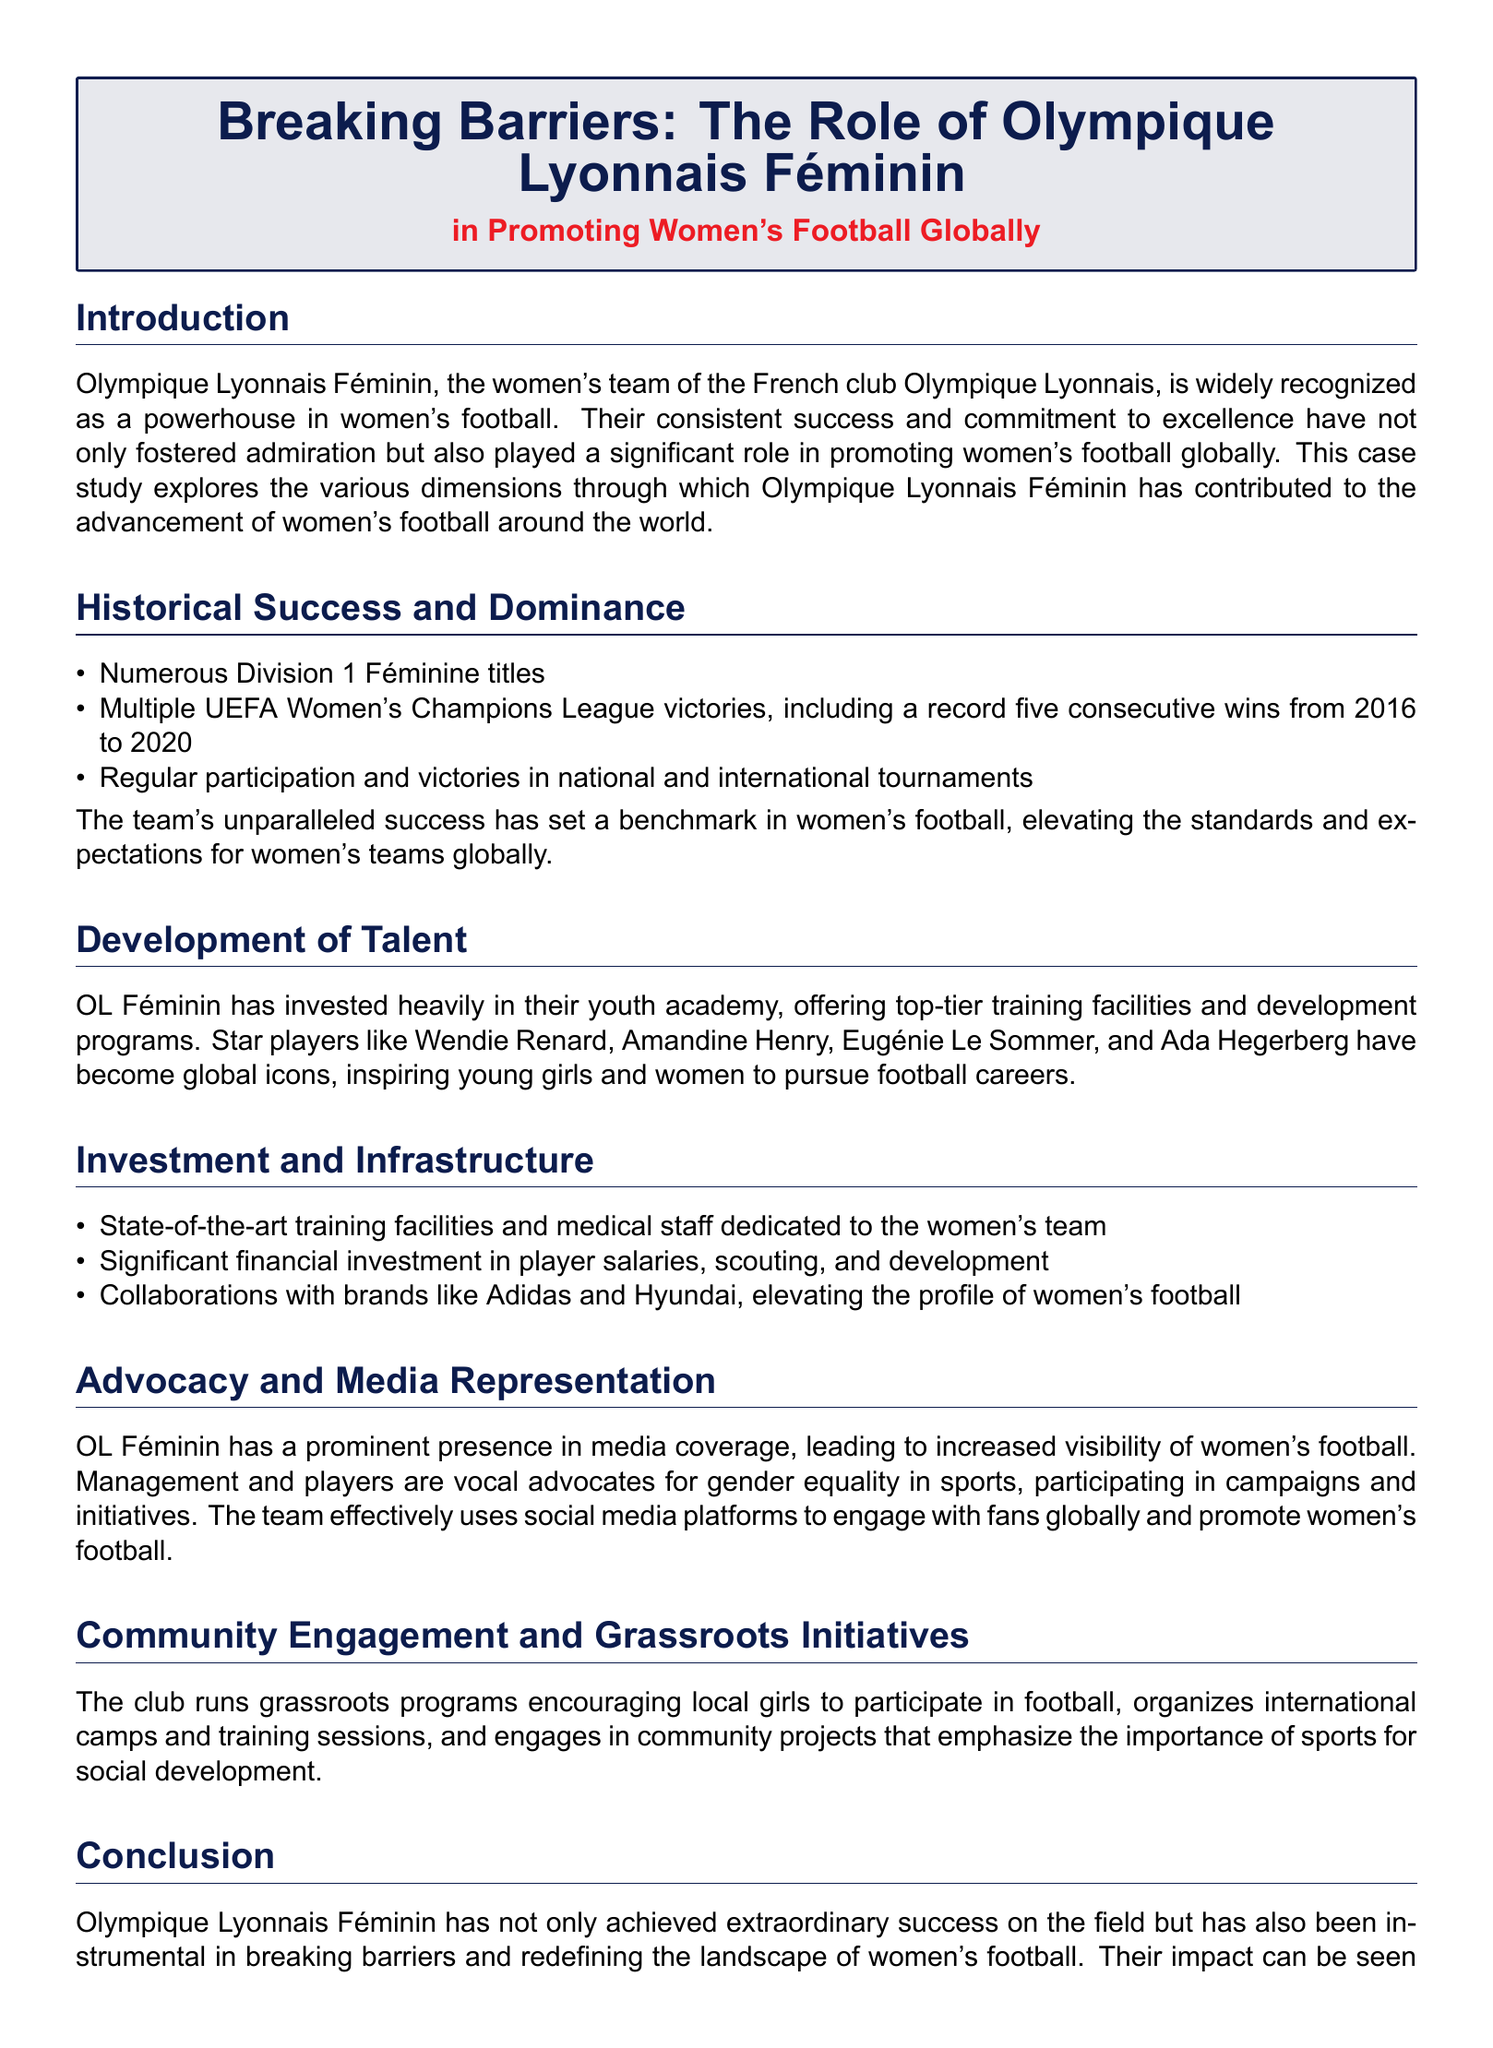What is the significant achievement of OL Féminin from 2016 to 2020? The document states that OL Féminin won multiple UEFA Women's Champions League victories, including a record five consecutive wins from 2016 to 2020.
Answer: five consecutive wins Who are some of the star players mentioned in the document? The case study highlights several star players such as Wendie Renard, Amandine Henry, Eugénie Le Sommer, and Ada Hegerberg.
Answer: Wendie Renard, Amandine Henry, Eugénie Le Sommer, Ada Hegerberg What has OL Féminin heavily invested in to promote women's football? The document mentions that OL Féminin has invested heavily in their youth academy, offering top-tier training facilities and development programs.
Answer: youth academy What is a key component of the club's advocacy efforts? According to the document, OL Féminin participates in campaigns and initiatives that promote gender equality in sports.
Answer: gender equality How many Division 1 Féminine titles has OL Féminin won? The case study does not specify an exact number of titles but mentions "numerous" Division 1 Féminine titles.
Answer: numerous What role does social media play for OL Féminin? The document indicates that OL Féminin uses social media platforms to engage with fans globally and promote women's football.
Answer: engage with fans What aspect of community engagement is highlighted in the document? The case study mentions that the club runs grassroots programs encouraging local girls to participate in football.
Answer: grassroots programs What kind of collaborations has OL Féminin engaged in? The document states that OL Féminin collaborates with brands like Adidas and Hyundai.
Answer: Adidas and Hyundai What is emphasized as important for social development in the club's community initiatives? The document mentions that the community projects emphasize the importance of sports for social development.
Answer: sports for social development 